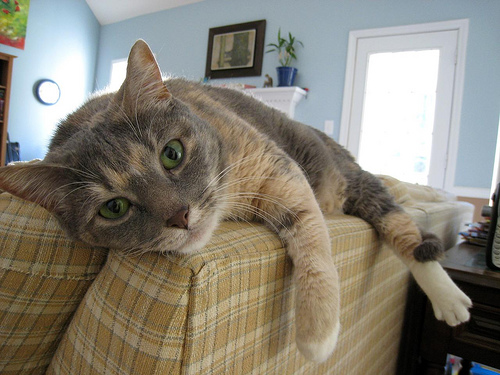How many cats are there? There is one cat in the image, comfortably lounging atop what appears to be a couch's armrest with a relaxed and somewhat curious expression. 